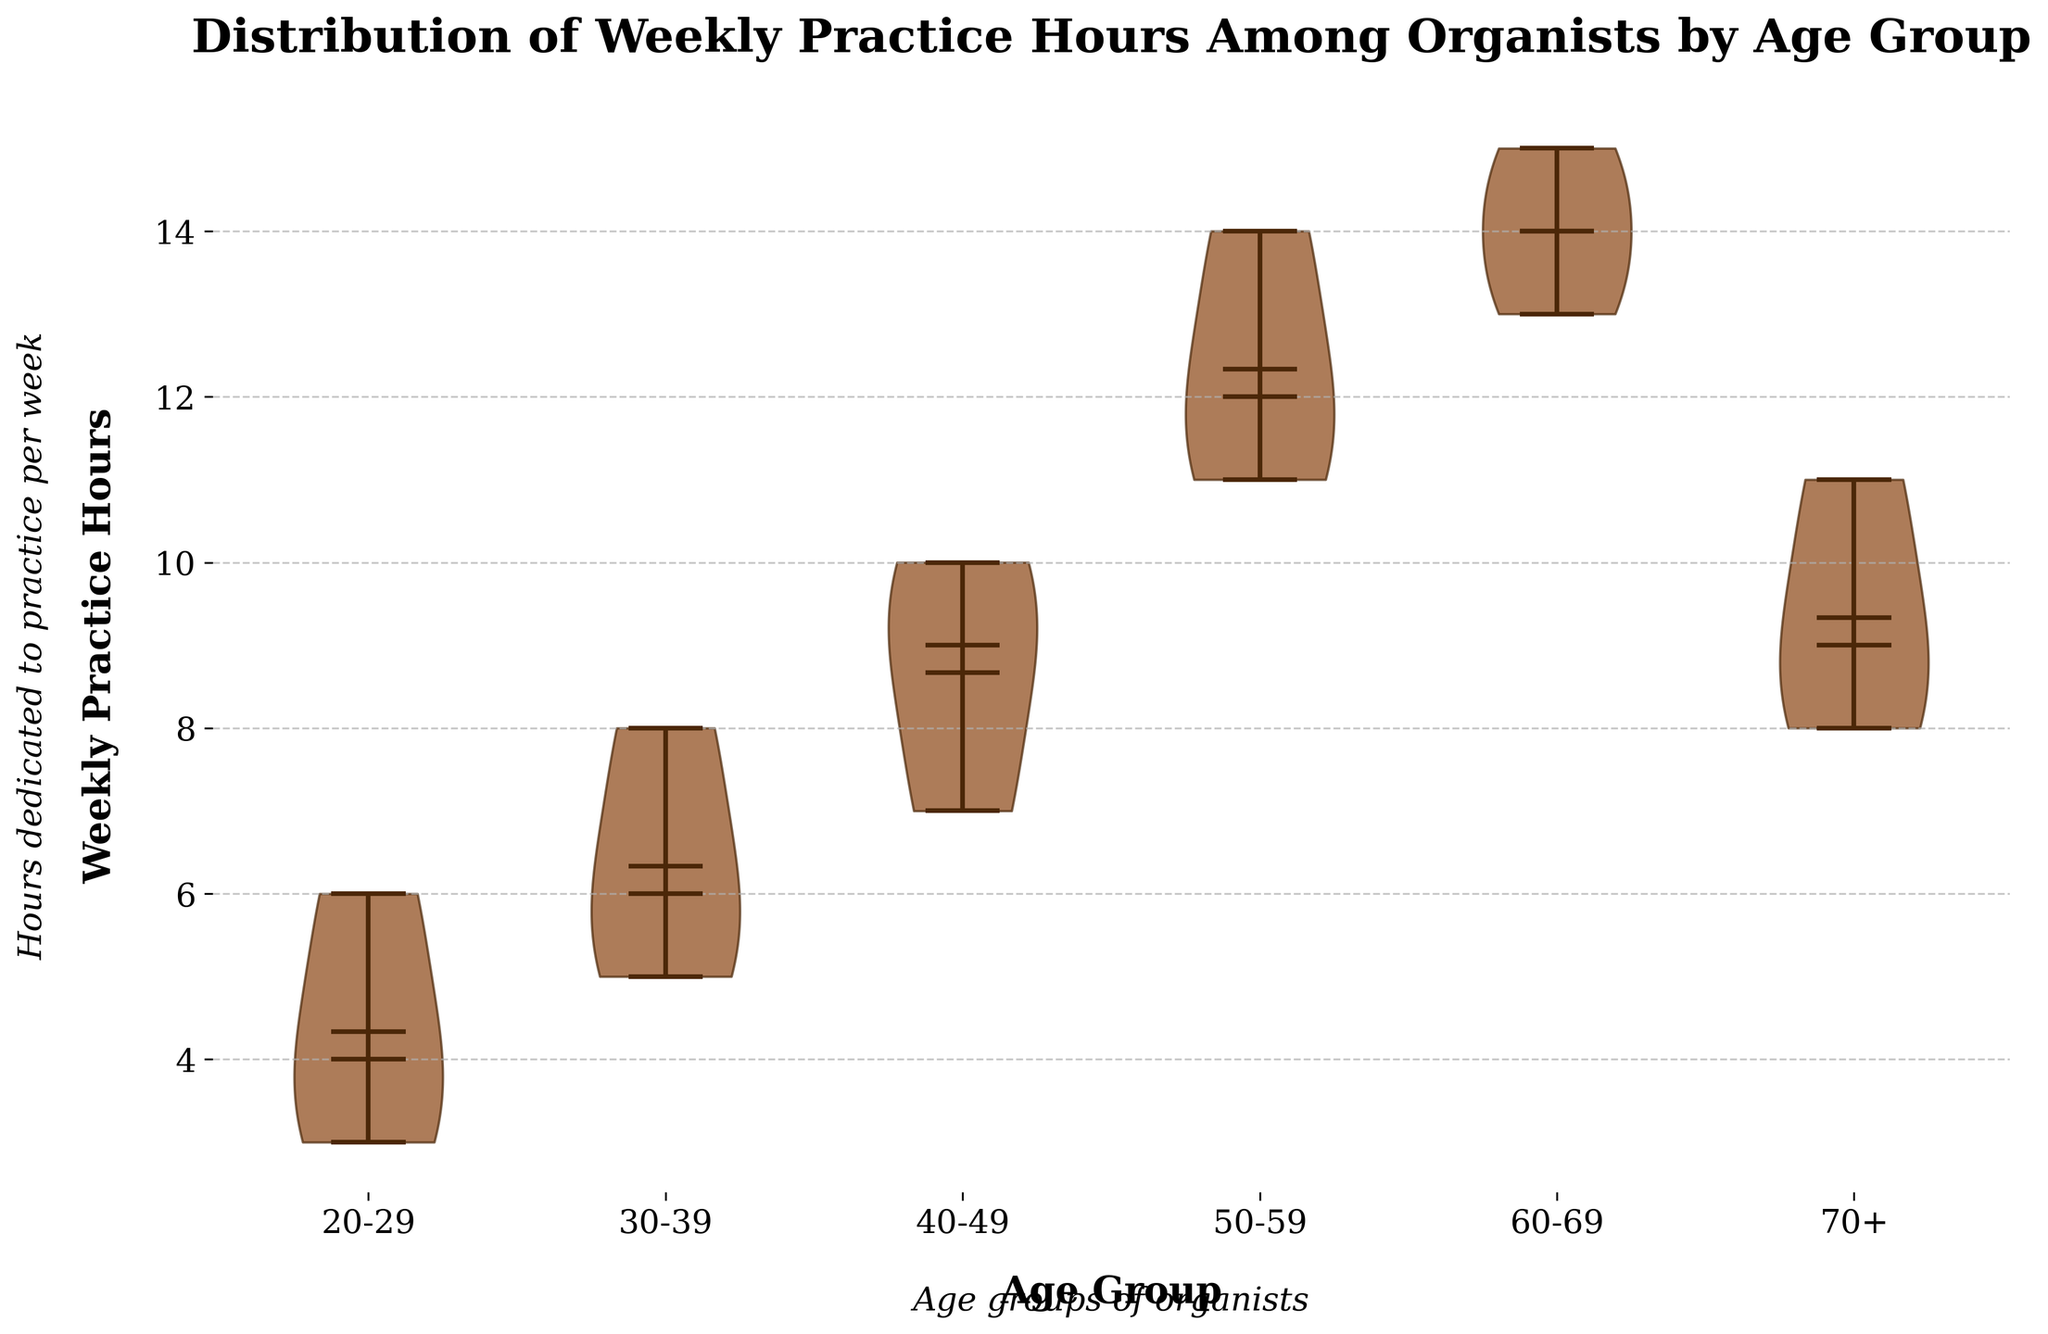What is the title of the chart? The title is usually located at the top of the chart and summarizes the main topic of the figure.
Answer: Distribution of Weekly Practice Hours Among Organists by Age Group What is the median weekly practice time for the 50-59 age group? Median values are typically indicated by a horizontal line inside the violin plot for each group.
Answer: 12 hours Which age group practices the most per week on average? To find this, you can compare the mean values indicated by the markers (often a dot or a line) for all age groups.
Answer: 60-69 How does the median weekly practice time for the 20-29 group compare to the 40-49 group? Compare the horizontal median lines in the violin plots for these two age groups.
Answer: The 40-49 group practices more with a median of 9 hours compared to the 20-29 group's 4 hours What is the range of practice hours for the 60-69 age group? The range can be found by looking at the extent of the violin plot for this group, from the minimum to the maximum values.
Answer: 13 to 15 hours Are there any outliers in the 30-39 age group? Outliers are typically shown as individual points outside the main body of the violin plot.
Answer: No Which age group has the smallest range of practice hours? Compare the ranges (difference between maximum and minimum values) of the practice hours for each age group.
Answer: 60-69 What is the shape of the distribution for the 70+ age group? The shape of the distribution in a violin plot can indicate the spread of the data and whether it is skewed.
Answer: Slightly skewed left What color is used for the main body of the violin plots? The color can usually be seen by looking at the fill of the violin plots.
Answer: Brown How do the practice hours of the 30-39 group compare to those of the 50-59 group? Compare the overall size and central tendency (like medians and means) of the violin plots for both age groups.
Answer: 50-59 practices more 